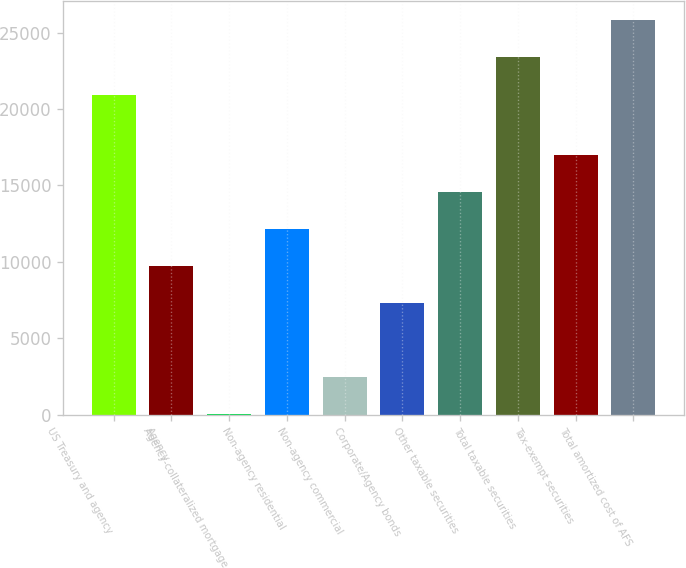<chart> <loc_0><loc_0><loc_500><loc_500><bar_chart><fcel>US Treasury and agency<fcel>Agency<fcel>Agency-collateralized mortgage<fcel>Non-agency residential<fcel>Non-agency commercial<fcel>Corporate/Agency bonds<fcel>Other taxable securities<fcel>Total taxable securities<fcel>Tax-exempt securities<fcel>Total amortized cost of AFS<nl><fcel>20945<fcel>9707.4<fcel>15<fcel>12130.5<fcel>2438.1<fcel>7284.3<fcel>14553.6<fcel>23368.1<fcel>16976.7<fcel>25791.2<nl></chart> 